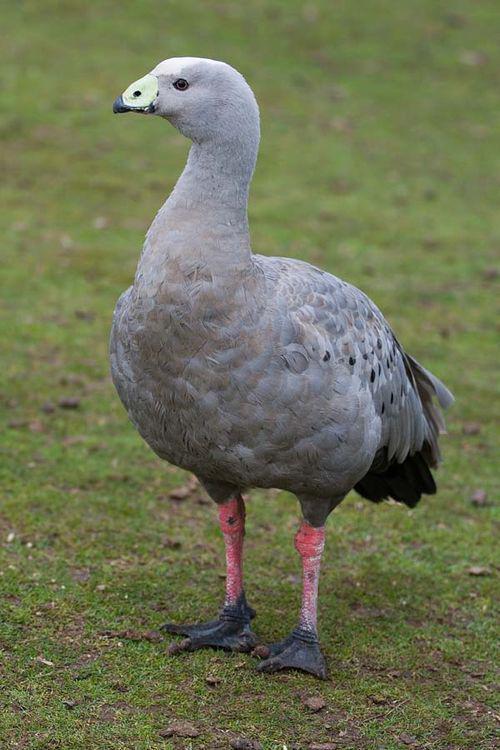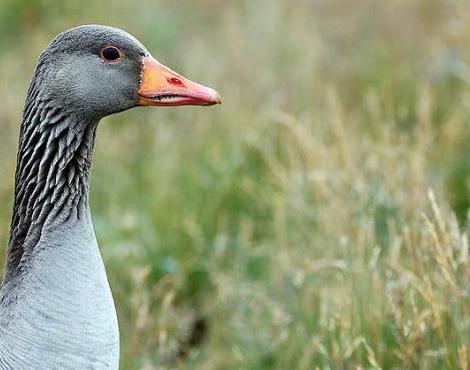The first image is the image on the left, the second image is the image on the right. Given the left and right images, does the statement "the goose on the right image is facing right" hold true? Answer yes or no. Yes. 